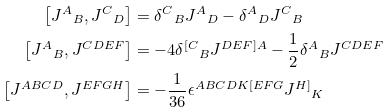<formula> <loc_0><loc_0><loc_500><loc_500>\left [ { J ^ { A } } _ { B } , { J ^ { C } } _ { D } \right ] & = { \delta ^ { C } } _ { B } { J ^ { A } } _ { D } - { \delta ^ { A } } _ { D } { J ^ { C } } _ { B } \\ \left [ { J ^ { A } } _ { B } , J ^ { C D E F } \right ] & = - 4 { \delta ^ { [ C } } _ { B } J ^ { D E F ] A } - \frac { 1 } { 2 } { \delta ^ { A } } _ { B } J ^ { C D E F } \\ \left [ J ^ { A B C D } , J ^ { E F G H } \right ] & = - \frac { 1 } { 3 6 } \epsilon ^ { A B C D K [ E F G } { J ^ { H ] } } _ { K }</formula> 